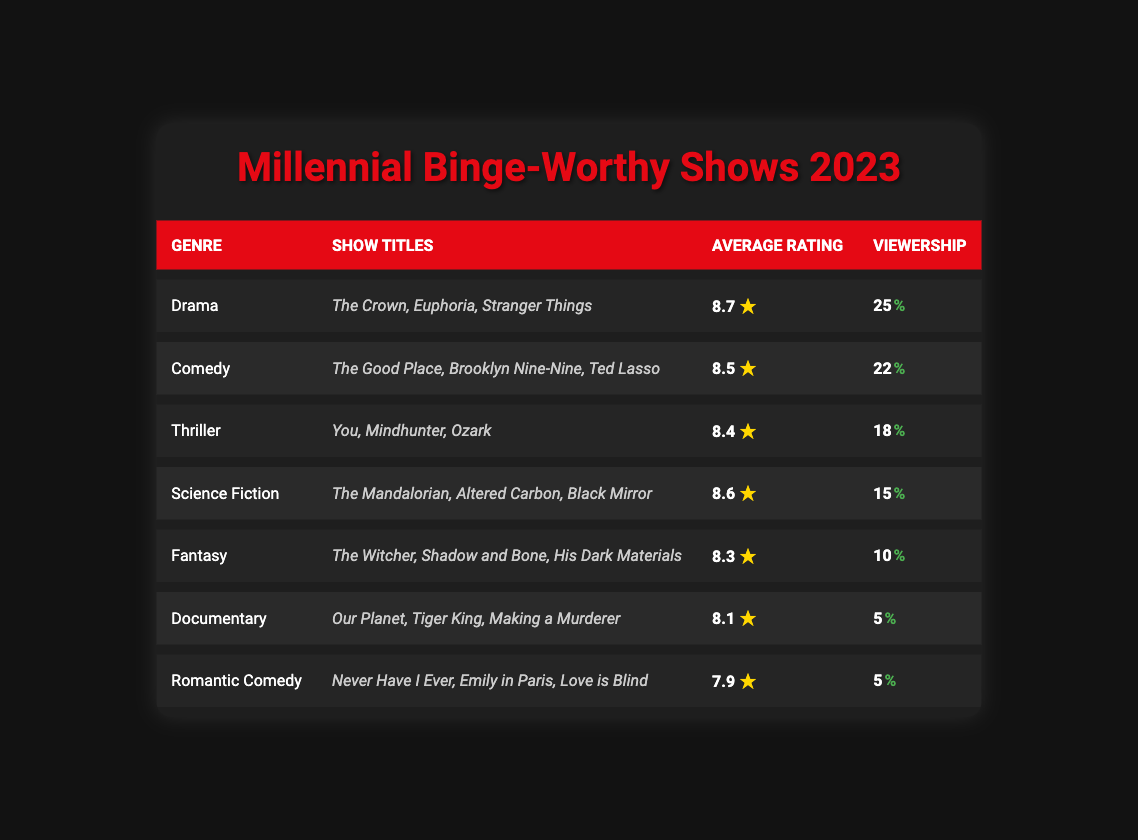What genre has the highest viewership percentage? By looking at the viewership percentages listed in the table for each genre, Drama has the highest percentage at 25%.
Answer: Drama Which show has the highest average rating? The average ratings for all shows are listed, and the highest rating of 8.7 belongs to the Drama genre with "The Crown," "Euphoria," and "Stranger Things."
Answer: The Crown, Euphoria, Stranger Things What is the average rating of the Comedy genre? The table shows the average rating for the Comedy genre as 8.5.
Answer: 8.5 Which genre has the lowest viewership percentage? The viewership percentages are compared, and both Documentary and Romantic Comedy genres have the lowest at 5%.
Answer: Documentary and Romantic Comedy How many genres have an average rating above 8.0? By counting the genres with average ratings listed in the table, there are 5 genres (Drama, Comedy, Thriller, Science Fiction, Fantasy) with ratings above 8.0.
Answer: 5 Is the viewership percentage higher for Thriller than for Science Fiction? Comparing the viewership percentages, Thriller has 18% while Science Fiction has 15%, confirming that Thriller has a higher percentage.
Answer: Yes What is the total viewership percentage of the top three genres? The viewership percentages of the top three genres are summed: 25% (Drama) + 22% (Comedy) + 18% (Thriller) = 65%.
Answer: 65% Which genre has an average rating that is below 8.0? By examining the average ratings, both Documentary (8.1) and Romantic Comedy (7.9) genres have ratings below 8.0, with Romantic Comedy being the lowest.
Answer: Romantic Comedy How does the average rating of Fantasy compare to that of Thriller? The average rating for Fantasy is 8.3, while Thriller is 8.4. Since 8.4 is greater than 8.3, Thriller has a higher average rating.
Answer: Thriller has a higher average rating If we consider only the genres with an average rating above 8.3, which genres qualify? The genres with ratings above 8.3 are Drama (8.7), Comedy (8.5), and Thriller (8.4), excluding Fantasy, which is at 8.3.
Answer: Drama, Comedy, Thriller 